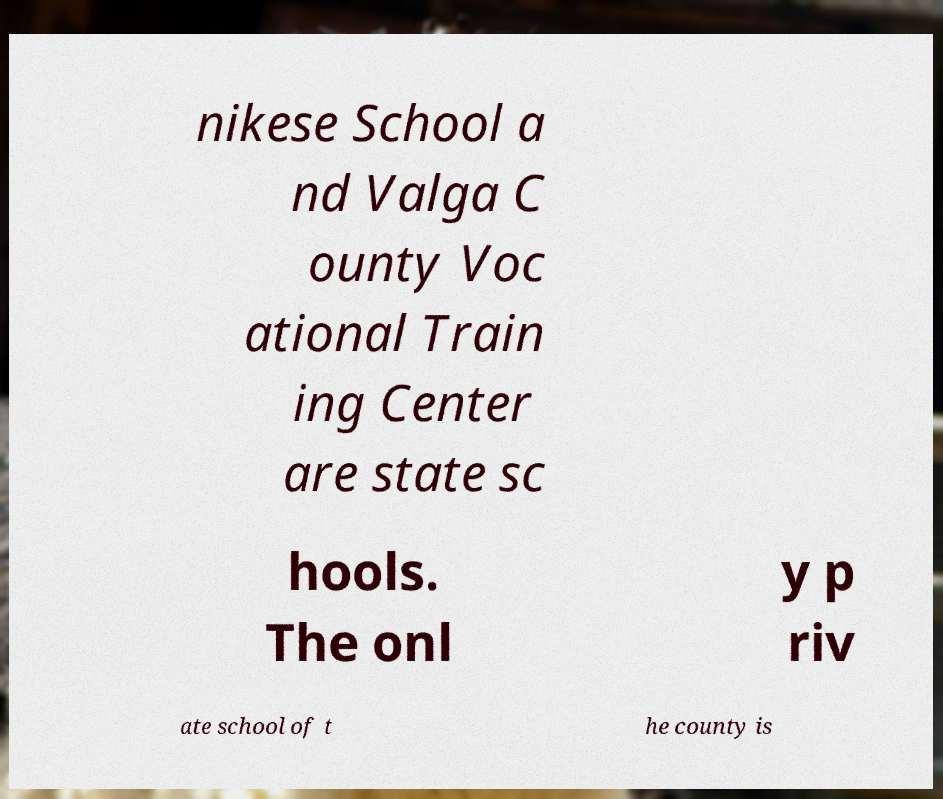Can you read and provide the text displayed in the image?This photo seems to have some interesting text. Can you extract and type it out for me? nikese School a nd Valga C ounty Voc ational Train ing Center are state sc hools. The onl y p riv ate school of t he county is 